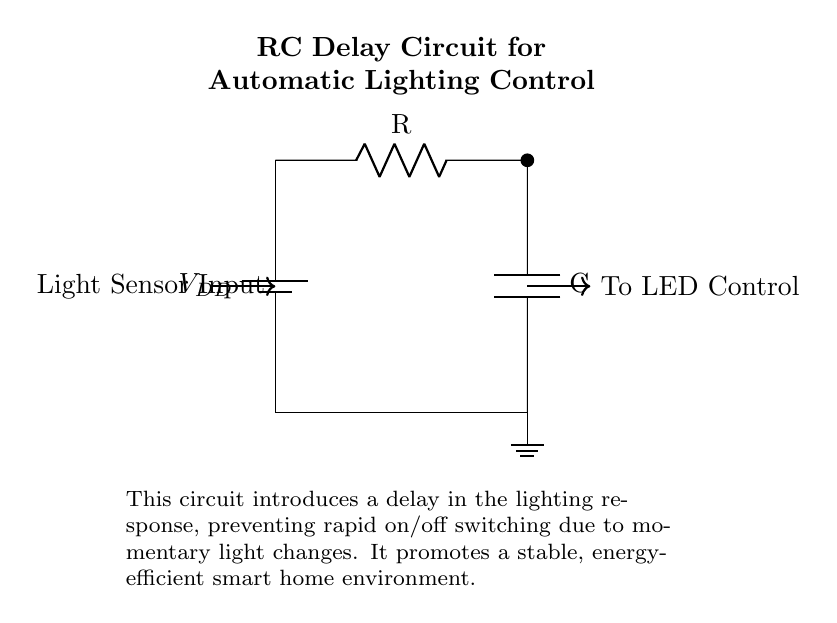What is the power supply voltage in this circuit? The circuit diagram labels the power supply as V sub DD, indicating it provides a voltage. However, an explicit value is not given in the visual; typically, this can be interpreted as a standard voltage for such applications, commonly five volts.
Answer: V sub DD What type of components are used in this circuit? The circuit features a resistor and a capacitor, labeled as R and C respectively. These are the key components that create the delay effect in the circuit.
Answer: Resistor and Capacitor What is the purpose of the RC delay circuit? The text in the circuit diagram explains that the circuit is designed to introduce a delay in lighting responses, preventing rapid on/off switching. This ensures more stable control of lighting which is useful in smart home environments.
Answer: Delay in lighting control How does the light sensor input affect the circuit? The light sensor input, shown coming from the left in the diagram, triggers the circuit to respond to light changes. The resistor and capacitor work together to delay the output sent to the LED control, preventing flickering.
Answer: It triggers the RC delay What happens to the output when light rapidly changes? As per the circuit design, momentary changes in light will not cause immediate output reactions due to the RC delay, meaning the LED control will stabilize the response by smoothing out rapid changes. This helps to avoid flickering.
Answer: It stabilizes the output What is the output control in this circuit? The output, indicated by the arrow to the right, goes to the LED control. This informs us that the circuit ultimately manages how the LED lights respond based on the delayed reaction to the light sensor.
Answer: To LED Control 